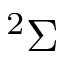Convert formula to latex. <formula><loc_0><loc_0><loc_500><loc_500>^ { 2 } \Sigma</formula> 